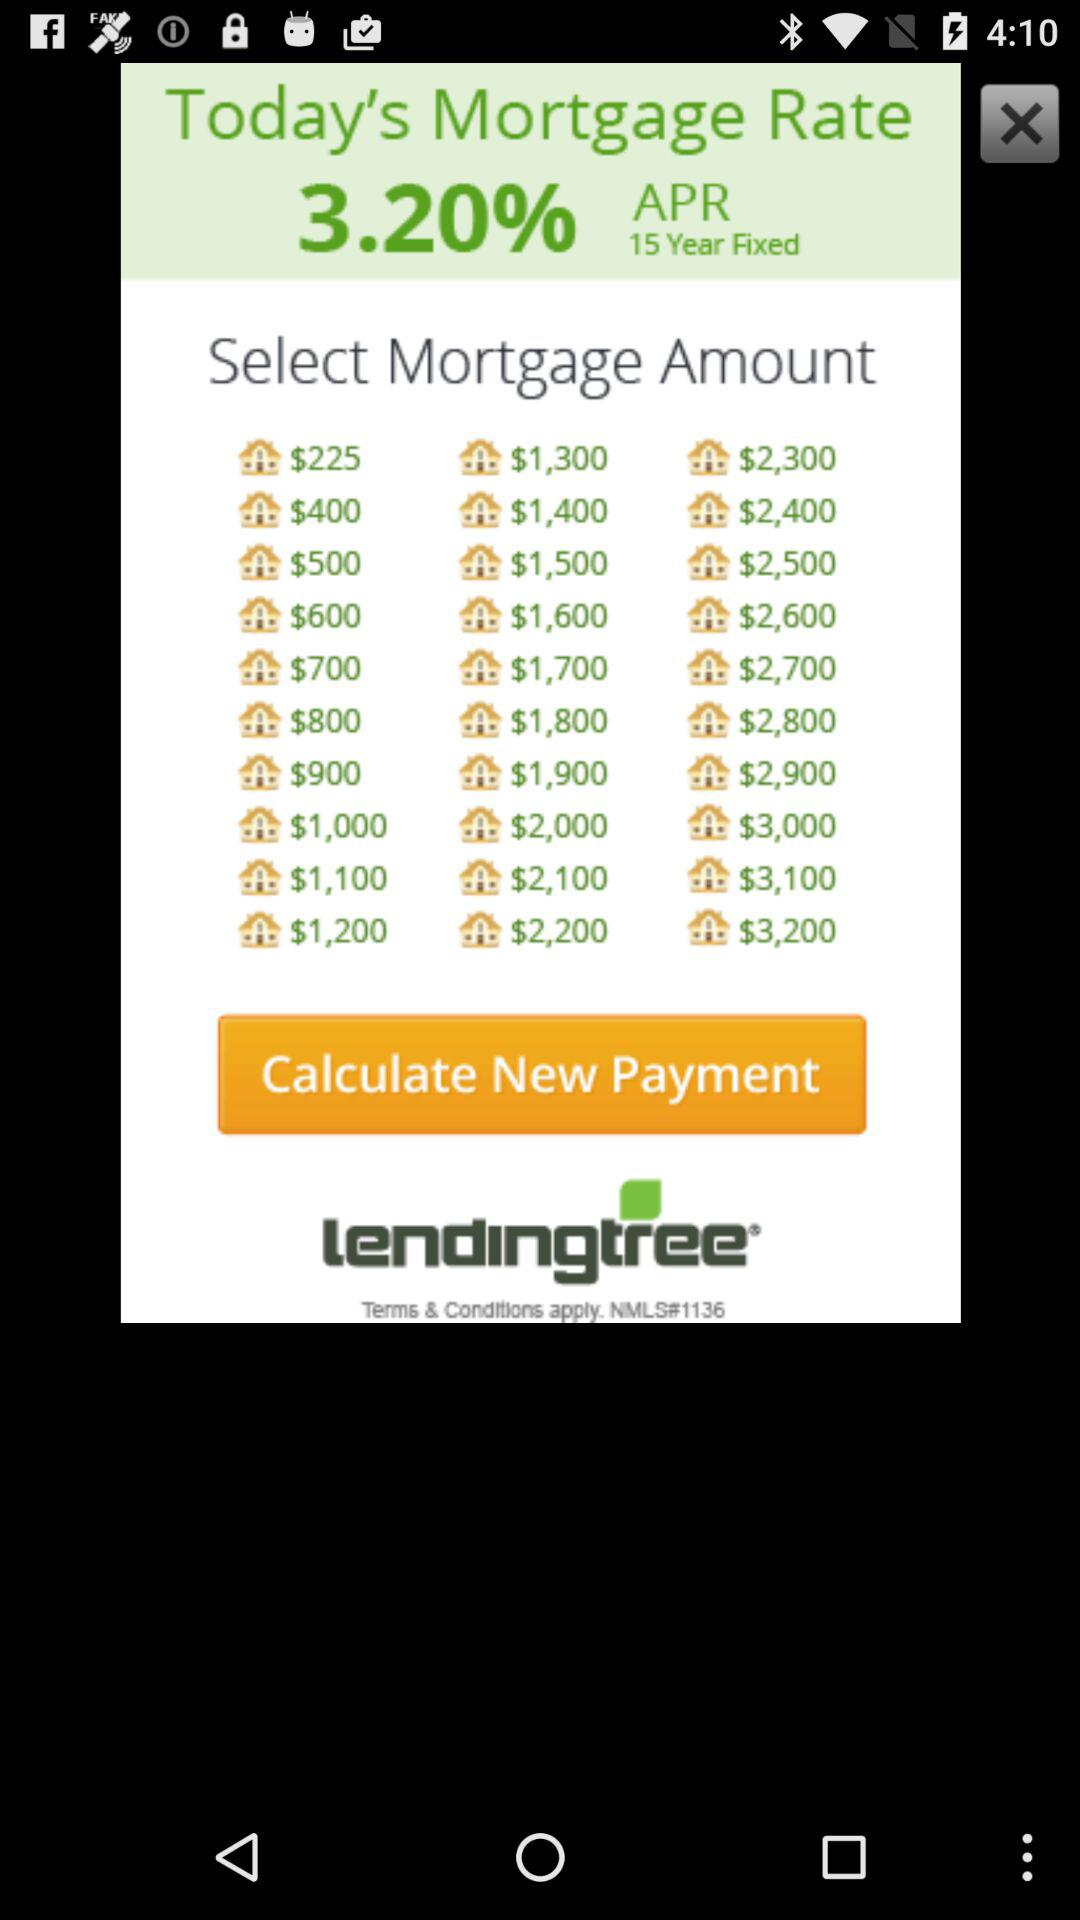Which option is selected?
When the provided information is insufficient, respond with <no answer>. <no answer> 